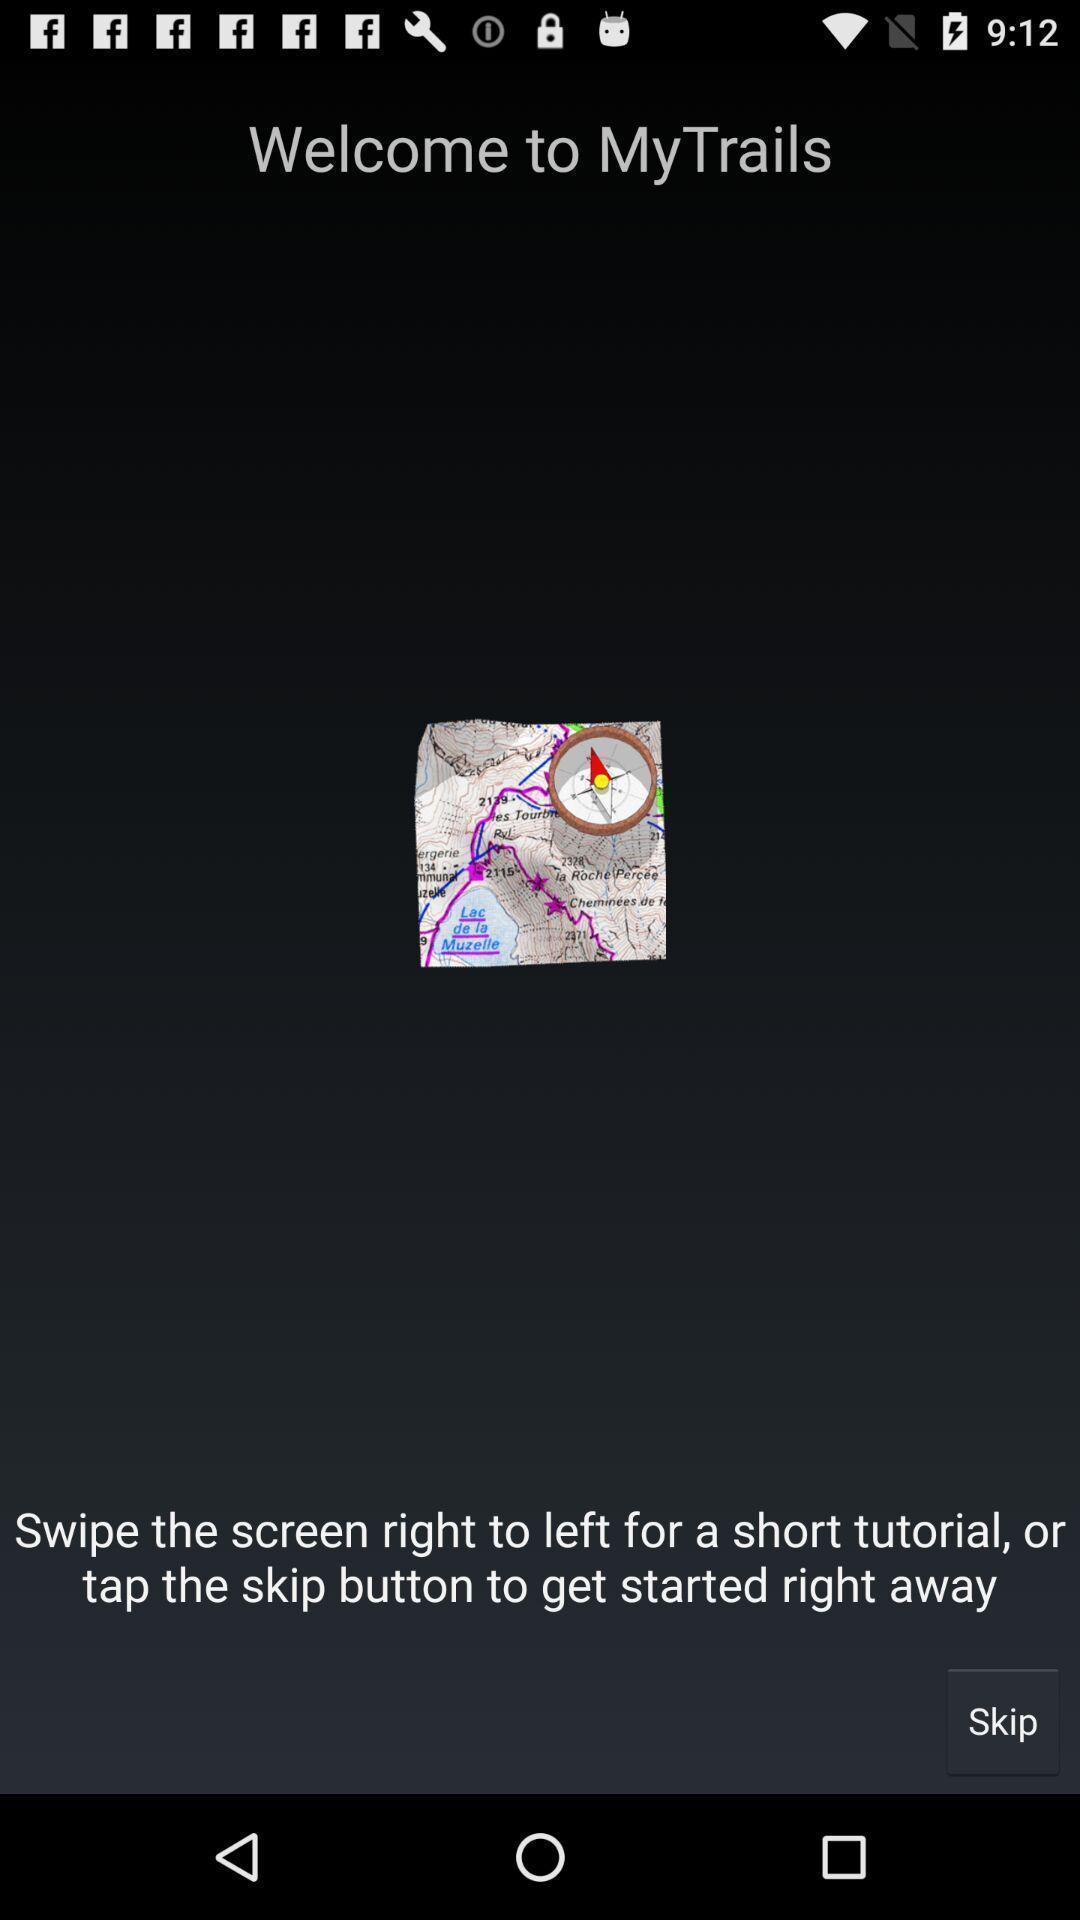Summarize the main components in this picture. Welcome page. 